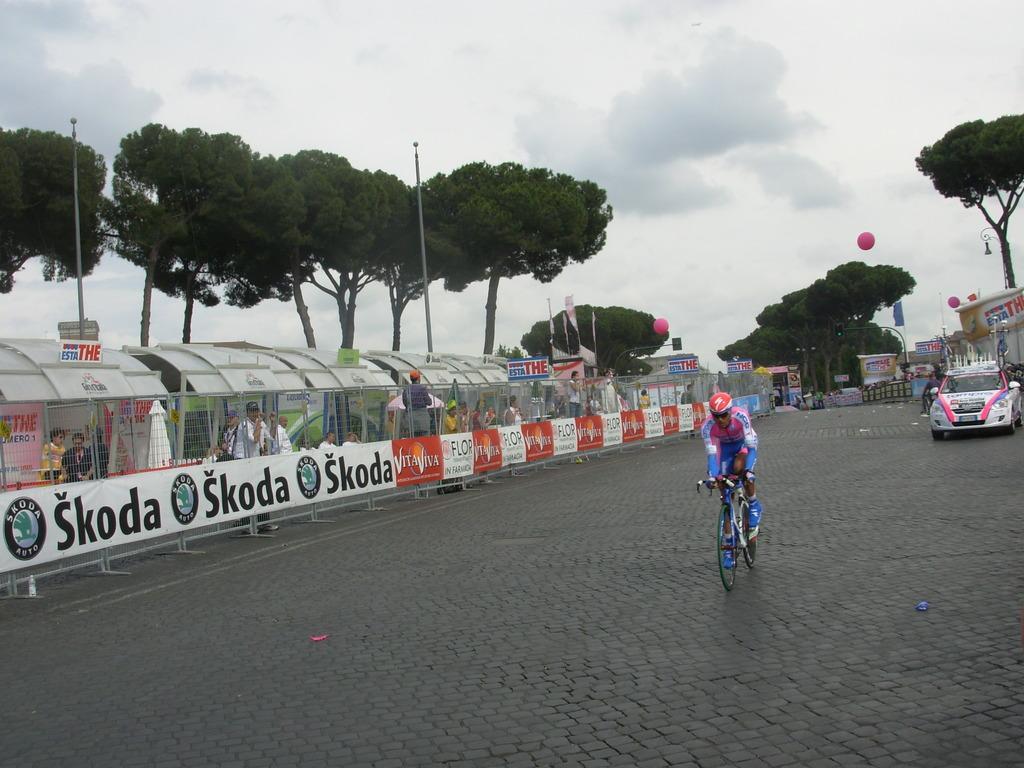Please provide a concise description of this image. In the center of the image we can see shed, fencing, some persons, poles, trees are there. On the right side of the image a car is there. In the center of the image we can see a man is riding a bicycle and wearing a helmet. In the background of the image a balloons, flags are present. At the top of the image clouds are present in the sky. At the bottom of the image ground is there. 